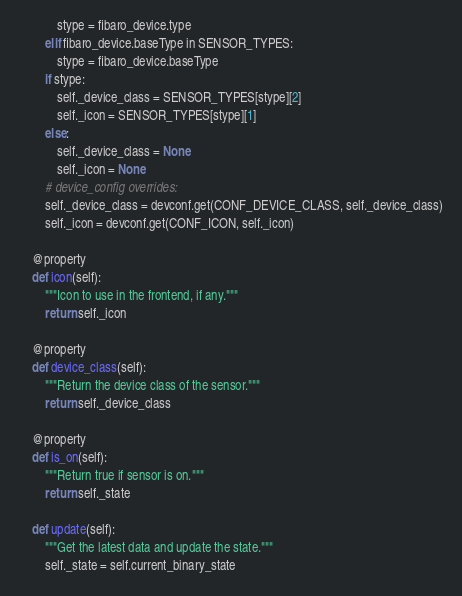Convert code to text. <code><loc_0><loc_0><loc_500><loc_500><_Python_>            stype = fibaro_device.type
        elif fibaro_device.baseType in SENSOR_TYPES:
            stype = fibaro_device.baseType
        if stype:
            self._device_class = SENSOR_TYPES[stype][2]
            self._icon = SENSOR_TYPES[stype][1]
        else:
            self._device_class = None
            self._icon = None
        # device_config overrides:
        self._device_class = devconf.get(CONF_DEVICE_CLASS, self._device_class)
        self._icon = devconf.get(CONF_ICON, self._icon)

    @property
    def icon(self):
        """Icon to use in the frontend, if any."""
        return self._icon

    @property
    def device_class(self):
        """Return the device class of the sensor."""
        return self._device_class

    @property
    def is_on(self):
        """Return true if sensor is on."""
        return self._state

    def update(self):
        """Get the latest data and update the state."""
        self._state = self.current_binary_state
</code> 